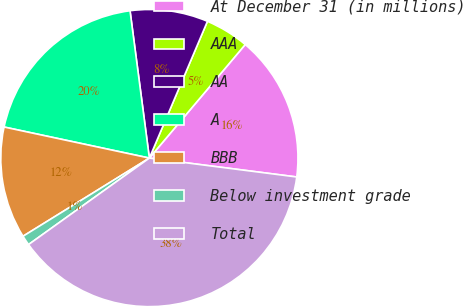Convert chart. <chart><loc_0><loc_0><loc_500><loc_500><pie_chart><fcel>At December 31 (in millions)<fcel>AAA<fcel>AA<fcel>A<fcel>BBB<fcel>Below investment grade<fcel>Total<nl><fcel>15.87%<fcel>4.77%<fcel>8.47%<fcel>19.57%<fcel>12.17%<fcel>1.07%<fcel>38.08%<nl></chart> 